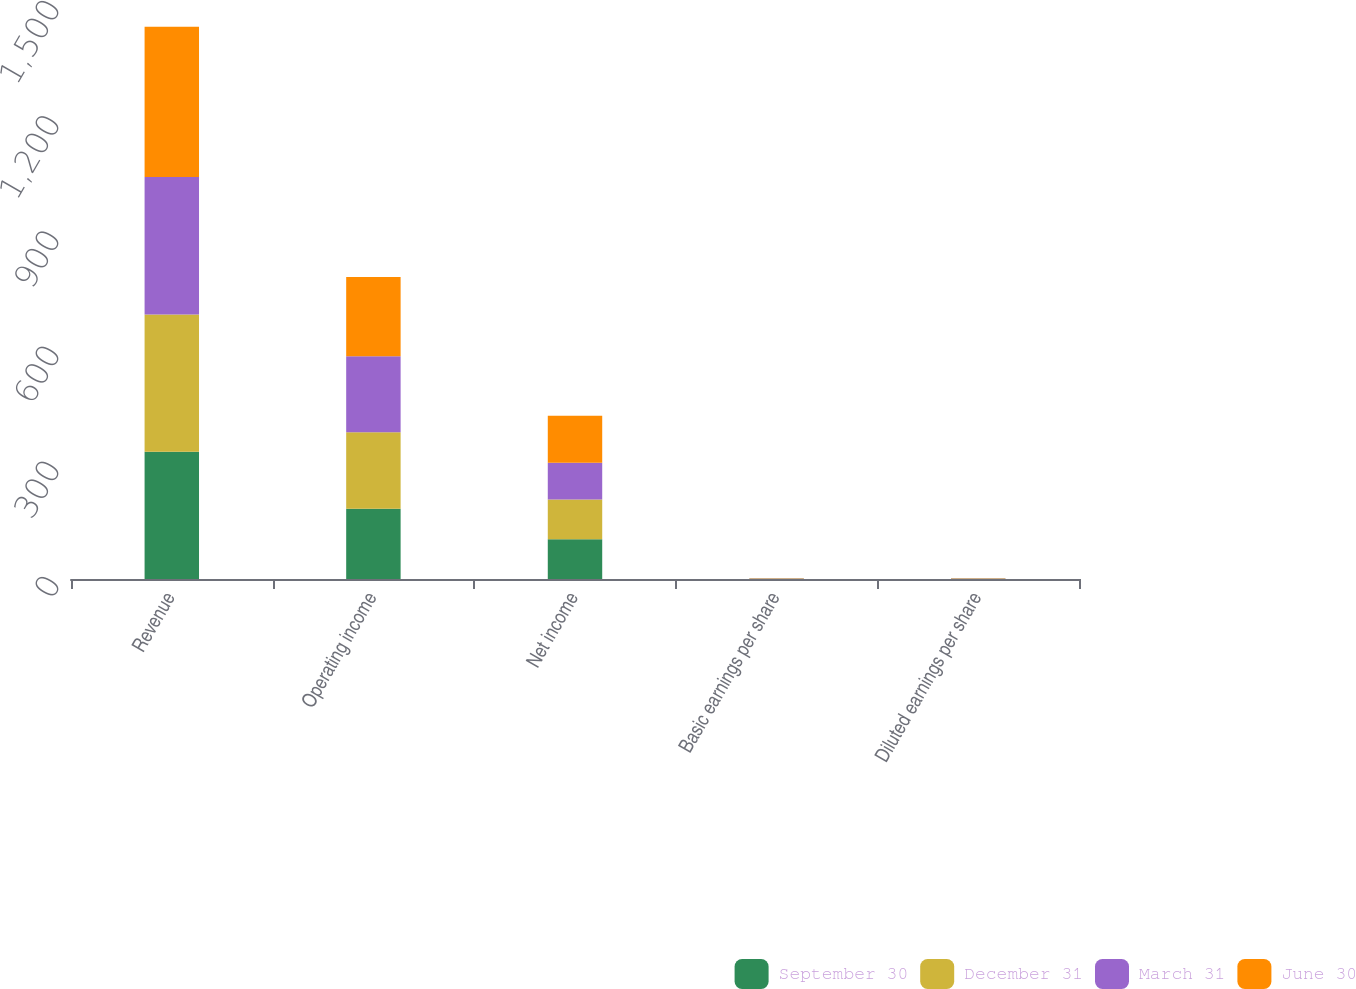<chart> <loc_0><loc_0><loc_500><loc_500><stacked_bar_chart><ecel><fcel>Revenue<fcel>Operating income<fcel>Net income<fcel>Basic earnings per share<fcel>Diluted earnings per share<nl><fcel>September 30<fcel>331.2<fcel>182.9<fcel>103.5<fcel>0.69<fcel>0.68<nl><fcel>December 31<fcel>357.6<fcel>199.5<fcel>103.5<fcel>0.7<fcel>0.68<nl><fcel>March 31<fcel>357.9<fcel>197.8<fcel>95.5<fcel>0.65<fcel>0.63<nl><fcel>June 30<fcel>391.6<fcel>206.2<fcel>122.6<fcel>0.83<fcel>0.8<nl></chart> 